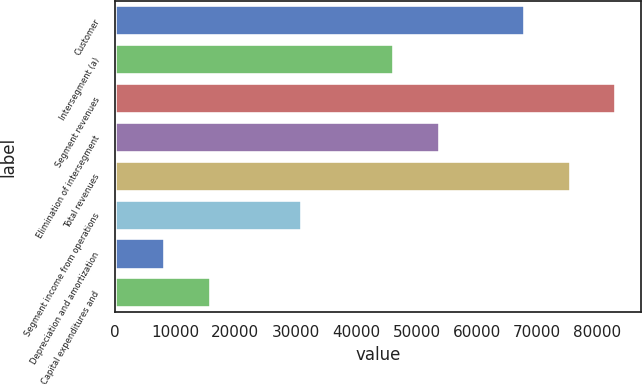<chart> <loc_0><loc_0><loc_500><loc_500><bar_chart><fcel>Customer<fcel>Intersegment (a)<fcel>Segment revenues<fcel>Elimination of intersegment<fcel>Total revenues<fcel>Segment income from operations<fcel>Depreciation and amortization<fcel>Capital expenditures and<nl><fcel>67921<fcel>46308<fcel>83122<fcel>53908.5<fcel>75521.5<fcel>31107<fcel>8305.5<fcel>15906<nl></chart> 